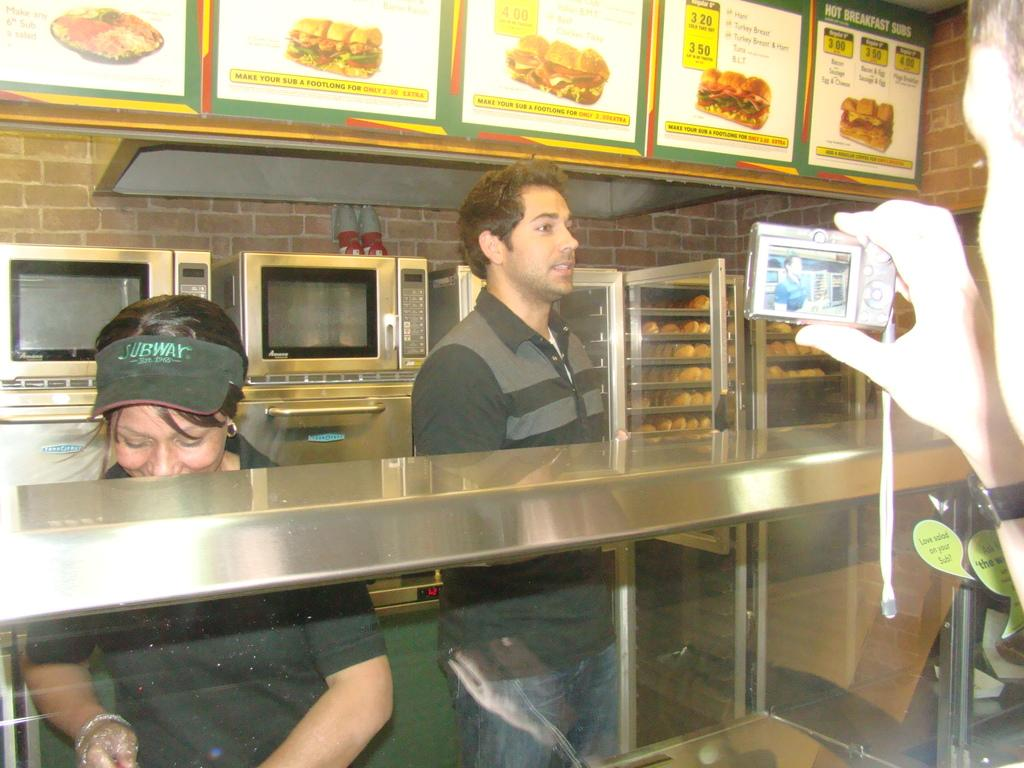<image>
Present a compact description of the photo's key features. People serving food in front of a menu that says "Hot Breakfast Subs". 